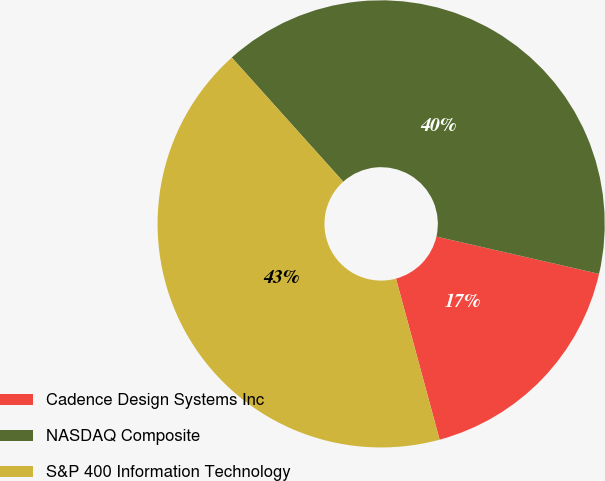Convert chart. <chart><loc_0><loc_0><loc_500><loc_500><pie_chart><fcel>Cadence Design Systems Inc<fcel>NASDAQ Composite<fcel>S&P 400 Information Technology<nl><fcel>17.2%<fcel>40.23%<fcel>42.56%<nl></chart> 